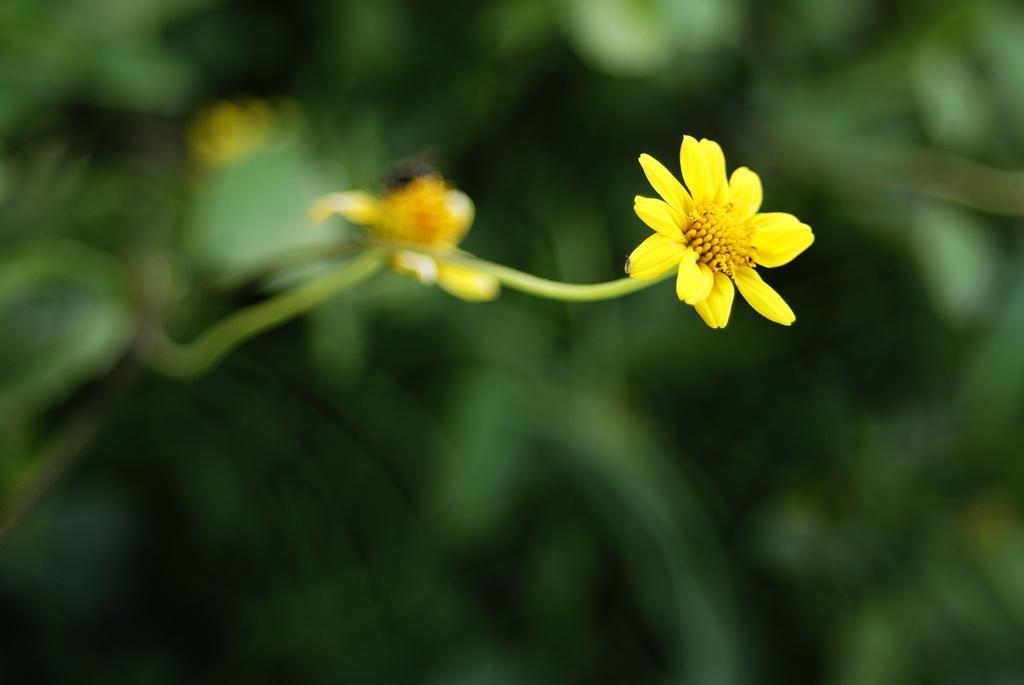Describe this image in one or two sentences. In this image I can see two yellow color flowers to the stems. In the background I can see the green color leaves. 